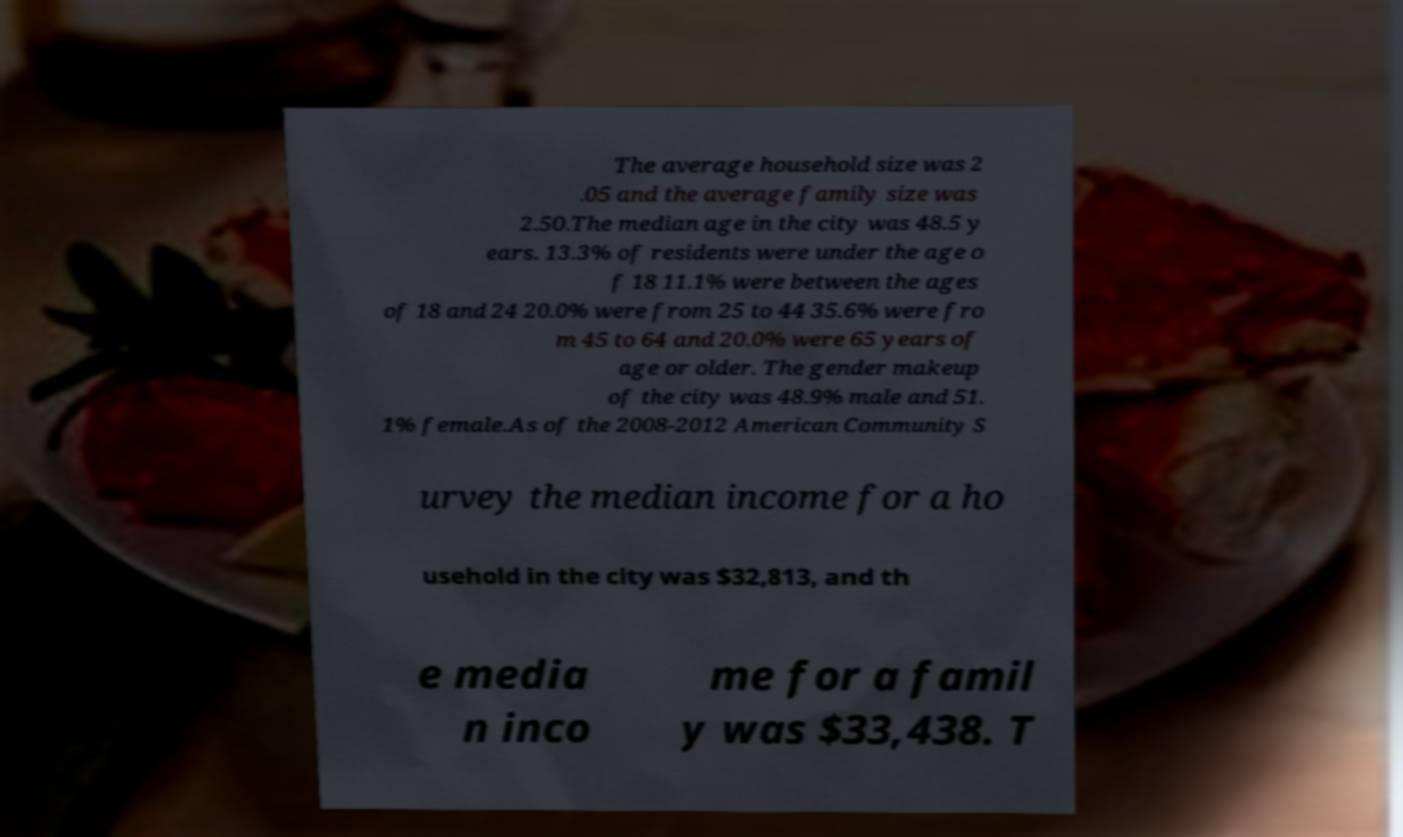For documentation purposes, I need the text within this image transcribed. Could you provide that? The average household size was 2 .05 and the average family size was 2.50.The median age in the city was 48.5 y ears. 13.3% of residents were under the age o f 18 11.1% were between the ages of 18 and 24 20.0% were from 25 to 44 35.6% were fro m 45 to 64 and 20.0% were 65 years of age or older. The gender makeup of the city was 48.9% male and 51. 1% female.As of the 2008-2012 American Community S urvey the median income for a ho usehold in the city was $32,813, and th e media n inco me for a famil y was $33,438. T 